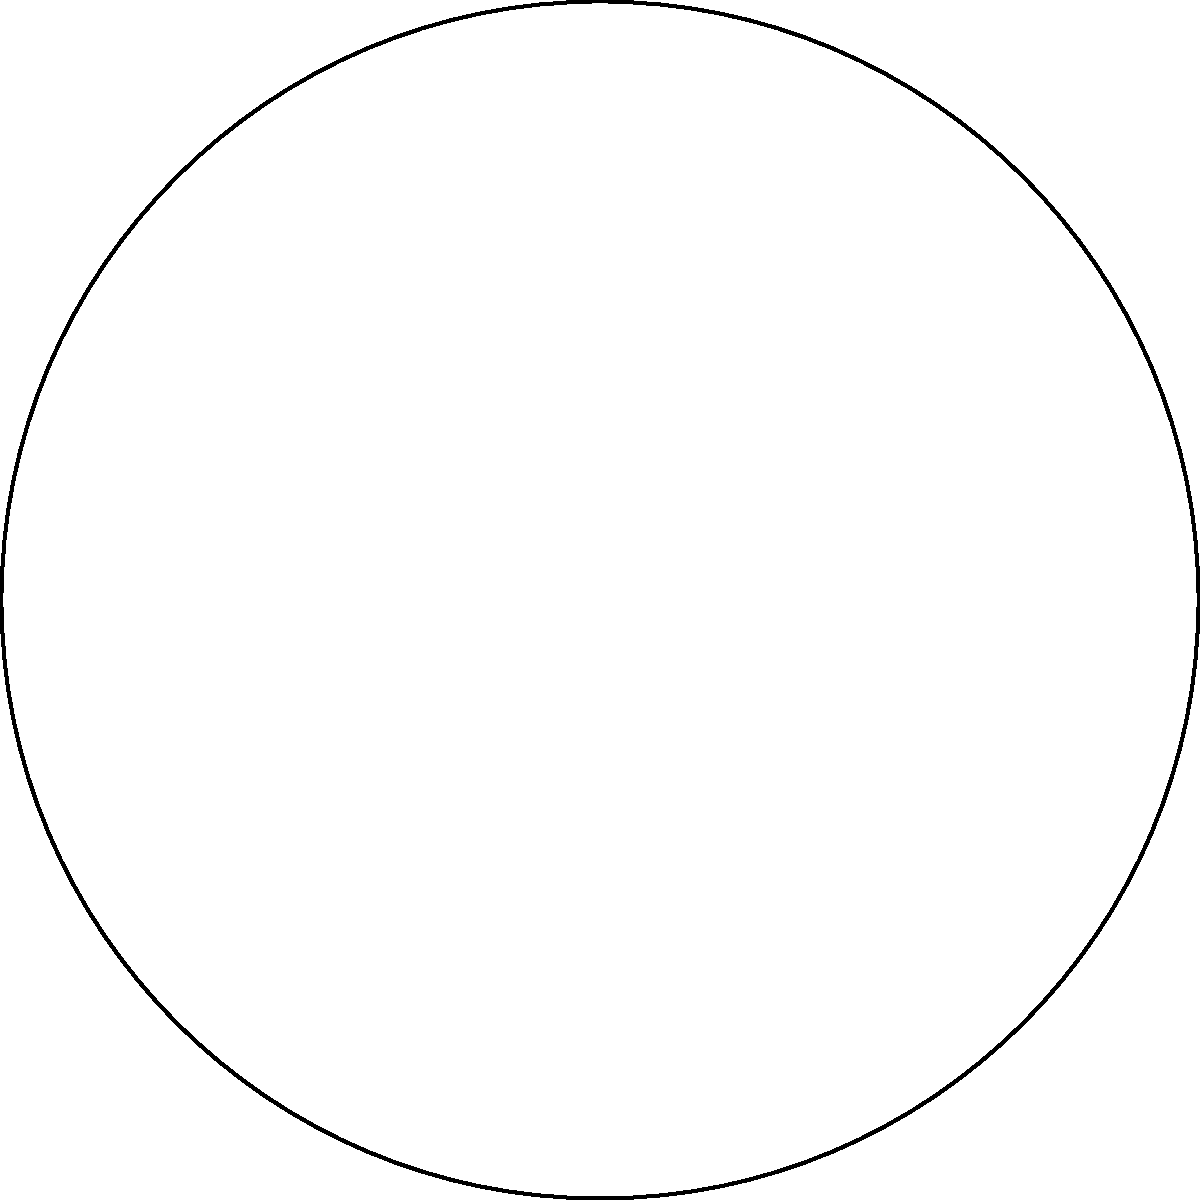A circular bird feeder is divided into sections for different types of bird feed. If one section occupies a central angle of 72°, what fraction of the entire bird feeder does this section represent? To solve this problem, let's follow these logical steps:

1. Recall that a complete circle has 360°.

2. The given section occupies a central angle of 72°.

3. To find the fraction of the entire bird feeder that this section represents, we need to divide the angle of the section by the total angle of the circle:

   $$\frac{\text{Section Angle}}{\text{Total Circle Angle}} = \frac{72^\circ}{360^\circ}$$

4. Simplify this fraction:
   $$\frac{72^\circ}{360^\circ} = \frac{1}{5}$$

5. Therefore, the section occupies $\frac{1}{5}$ or one-fifth of the entire bird feeder.

This logical approach allows us to determine the exact fraction of the bird feeder represented by the given section, which is useful for planning feed distribution and understanding the feeder's capacity.
Answer: $\frac{1}{5}$ 